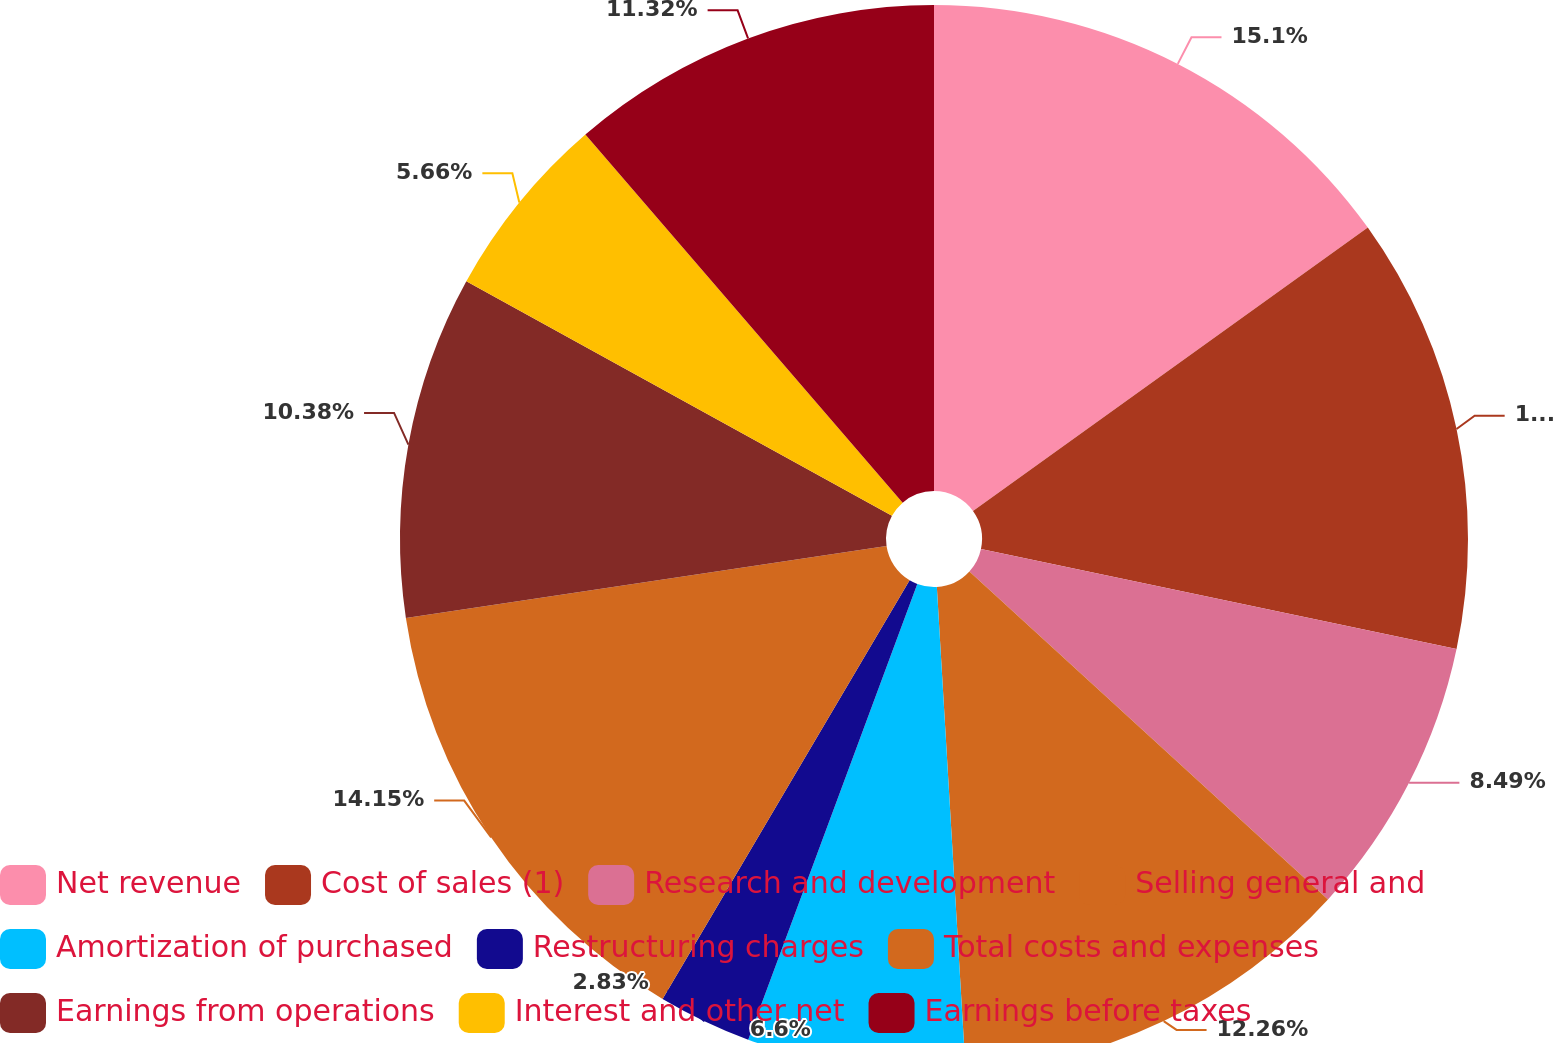Convert chart. <chart><loc_0><loc_0><loc_500><loc_500><pie_chart><fcel>Net revenue<fcel>Cost of sales (1)<fcel>Research and development<fcel>Selling general and<fcel>Amortization of purchased<fcel>Restructuring charges<fcel>Total costs and expenses<fcel>Earnings from operations<fcel>Interest and other net<fcel>Earnings before taxes<nl><fcel>15.09%<fcel>13.21%<fcel>8.49%<fcel>12.26%<fcel>6.6%<fcel>2.83%<fcel>14.15%<fcel>10.38%<fcel>5.66%<fcel>11.32%<nl></chart> 